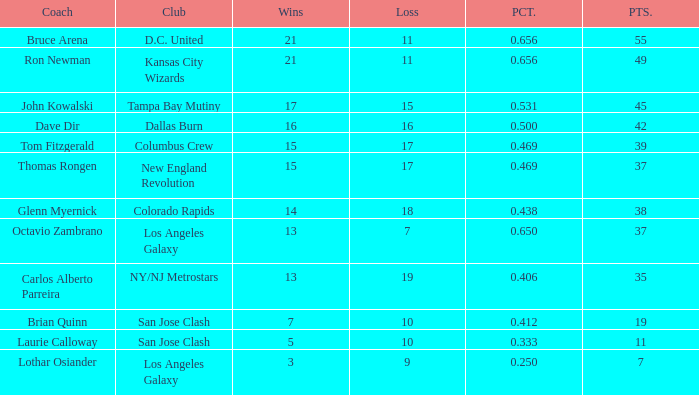Could you parse the entire table as a dict? {'header': ['Coach', 'Club', 'Wins', 'Loss', 'PCT.', 'PTS.'], 'rows': [['Bruce Arena', 'D.C. United', '21', '11', '0.656', '55'], ['Ron Newman', 'Kansas City Wizards', '21', '11', '0.656', '49'], ['John Kowalski', 'Tampa Bay Mutiny', '17', '15', '0.531', '45'], ['Dave Dir', 'Dallas Burn', '16', '16', '0.500', '42'], ['Tom Fitzgerald', 'Columbus Crew', '15', '17', '0.469', '39'], ['Thomas Rongen', 'New England Revolution', '15', '17', '0.469', '37'], ['Glenn Myernick', 'Colorado Rapids', '14', '18', '0.438', '38'], ['Octavio Zambrano', 'Los Angeles Galaxy', '13', '7', '0.650', '37'], ['Carlos Alberto Parreira', 'NY/NJ Metrostars', '13', '19', '0.406', '35'], ['Brian Quinn', 'San Jose Clash', '7', '10', '0.412', '19'], ['Laurie Calloway', 'San Jose Clash', '5', '10', '0.333', '11'], ['Lothar Osiander', 'Los Angeles Galaxy', '3', '9', '0.250', '7']]} What is the aggregate of points when bruce arena achieves 21 wins? 55.0. 